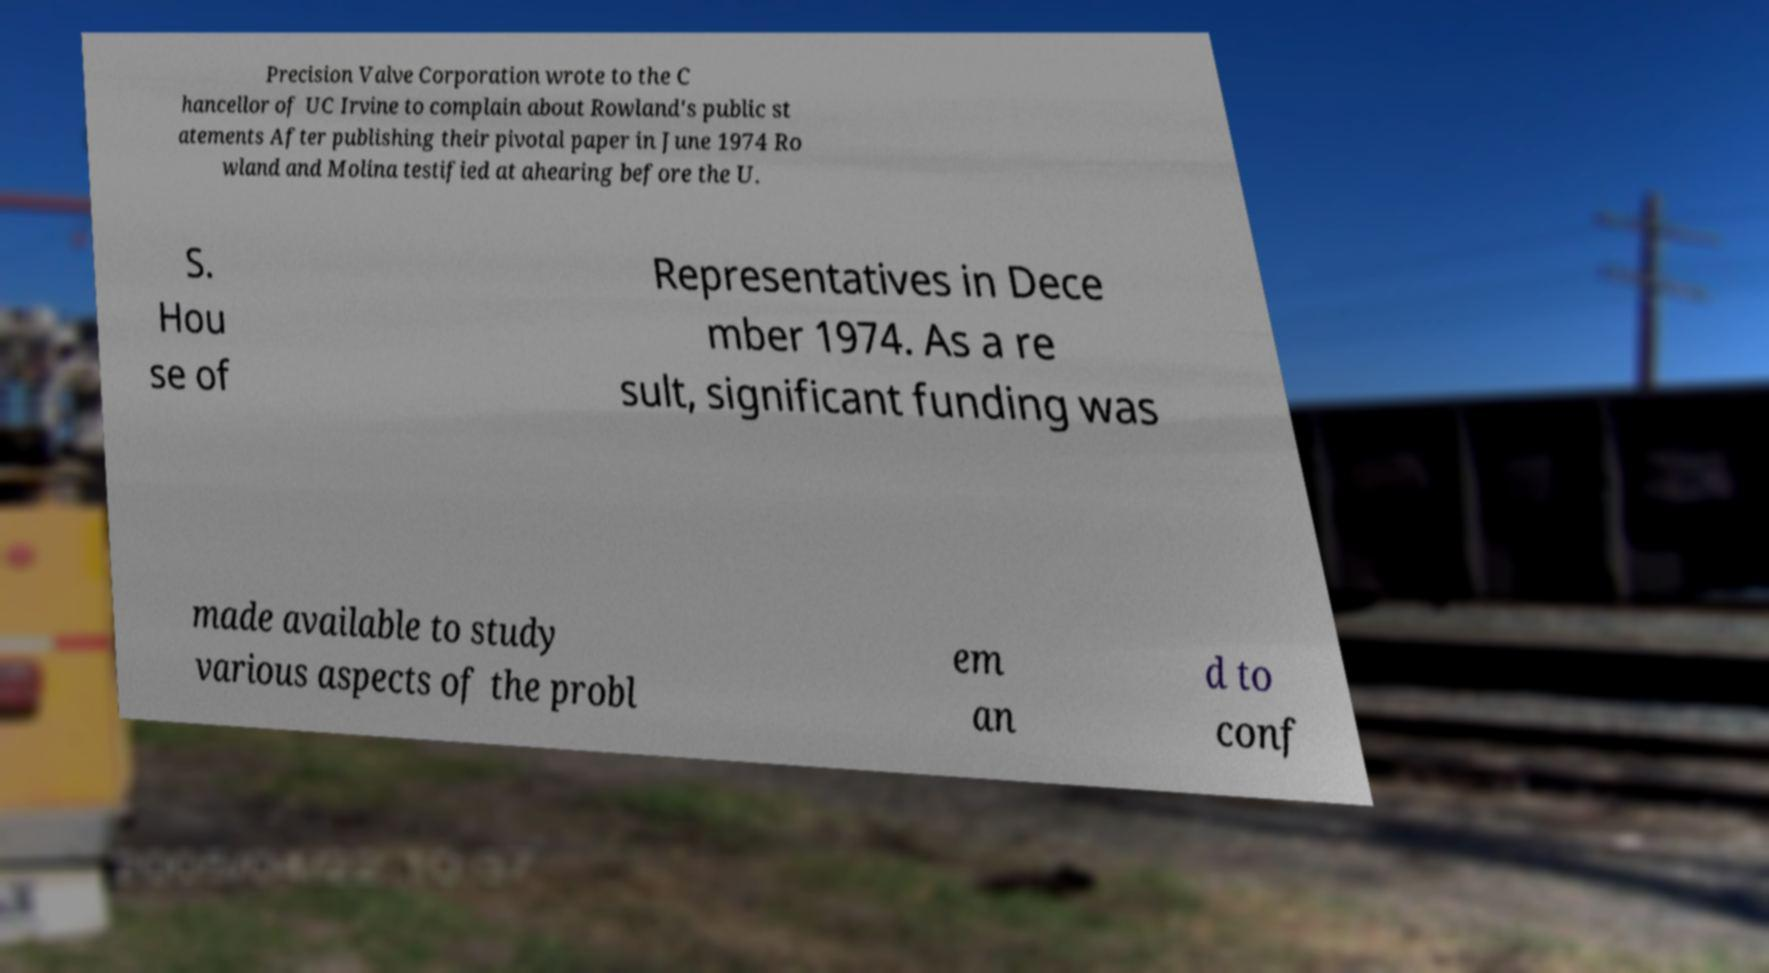Could you extract and type out the text from this image? Precision Valve Corporation wrote to the C hancellor of UC Irvine to complain about Rowland's public st atements After publishing their pivotal paper in June 1974 Ro wland and Molina testified at ahearing before the U. S. Hou se of Representatives in Dece mber 1974. As a re sult, significant funding was made available to study various aspects of the probl em an d to conf 